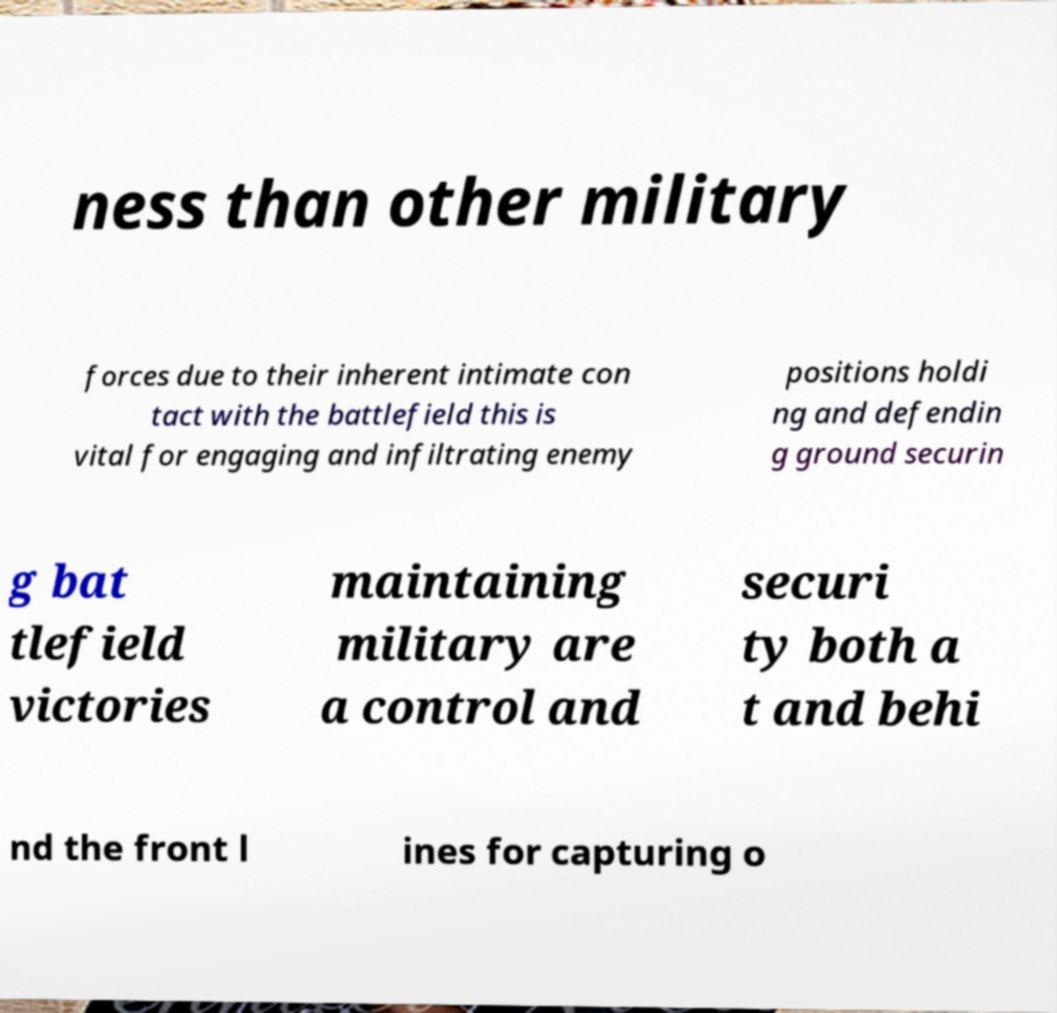Could you assist in decoding the text presented in this image and type it out clearly? ness than other military forces due to their inherent intimate con tact with the battlefield this is vital for engaging and infiltrating enemy positions holdi ng and defendin g ground securin g bat tlefield victories maintaining military are a control and securi ty both a t and behi nd the front l ines for capturing o 